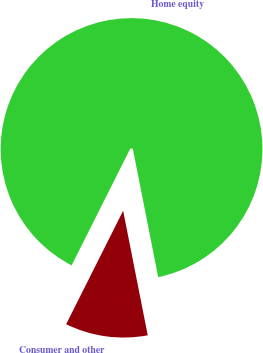Convert chart. <chart><loc_0><loc_0><loc_500><loc_500><pie_chart><fcel>Home equity<fcel>Consumer and other<nl><fcel>89.49%<fcel>10.51%<nl></chart> 